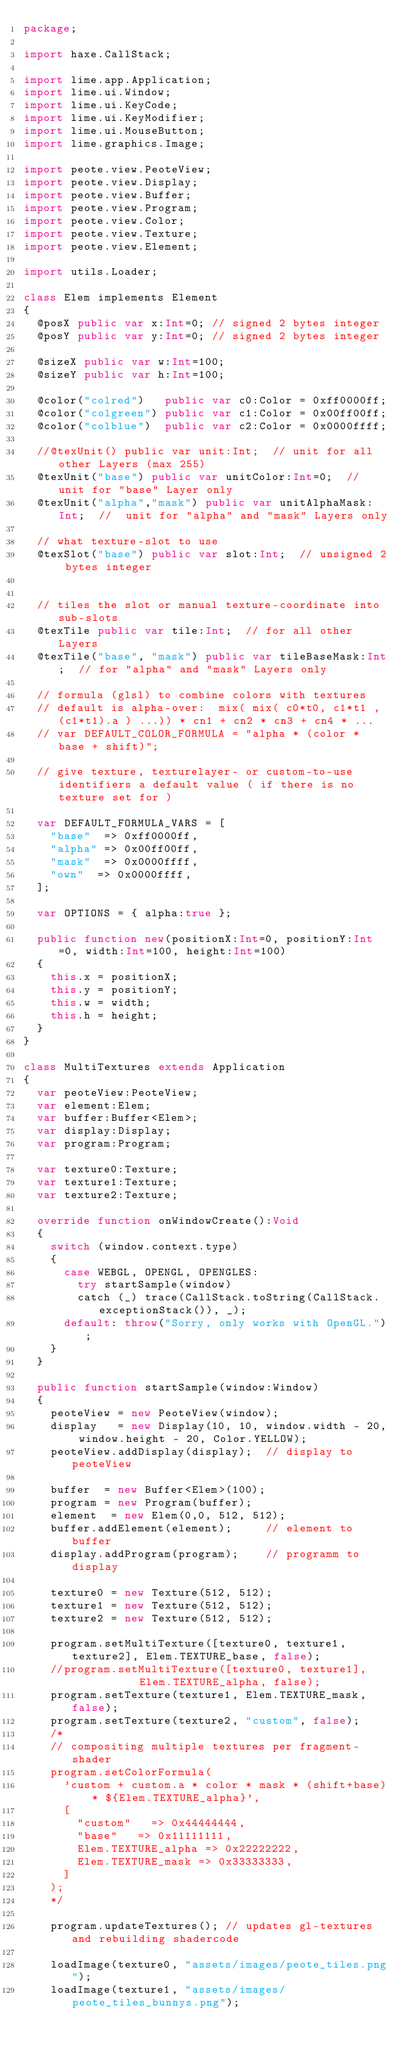<code> <loc_0><loc_0><loc_500><loc_500><_Haxe_>package;

import haxe.CallStack;

import lime.app.Application;
import lime.ui.Window;
import lime.ui.KeyCode;
import lime.ui.KeyModifier;
import lime.ui.MouseButton;
import lime.graphics.Image;

import peote.view.PeoteView;
import peote.view.Display;
import peote.view.Buffer;
import peote.view.Program;
import peote.view.Color;
import peote.view.Texture;
import peote.view.Element;

import utils.Loader;

class Elem implements Element
{
	@posX public var x:Int=0; // signed 2 bytes integer
	@posY public var y:Int=0; // signed 2 bytes integer
	
	@sizeX public var w:Int=100;
	@sizeY public var h:Int=100;
	
	@color("colred")   public var c0:Color = 0xff0000ff;
	@color("colgreen") public var c1:Color = 0x00ff00ff;
	@color("colblue")  public var c2:Color = 0x0000ffff;
		
	//@texUnit() public var unit:Int;  // unit for all other Layers (max 255)
	@texUnit("base") public var unitColor:Int=0;  //  unit for "base" Layer only
	@texUnit("alpha","mask") public var unitAlphaMask:Int;  //  unit for "alpha" and "mask" Layers only

	// what texture-slot to use
	@texSlot("base") public var slot:Int;  // unsigned 2 bytes integer


	// tiles the slot or manual texture-coordinate into sub-slots
	@texTile public var tile:Int;  // for all other Layers
	@texTile("base", "mask") public var tileBaseMask:Int;  // for "alpha" and "mask" Layers only

	// formula (glsl) to combine colors with textures
	// default is alpha-over:  mix( mix( c0*t0, c1*t1 , (c1*t1).a ) ...)) * cn1 + cn2 * cn3 + cn4 * ...
	// var DEFAULT_COLOR_FORMULA = "alpha * (color * base + shift)";

	// give texture, texturelayer- or custom-to-use identifiers a default value ( if there is no texture set for )
	
	var DEFAULT_FORMULA_VARS = [
		"base"  => 0xff0000ff,
		"alpha" => 0x00ff00ff,
		"mask"  => 0x0000ffff,
		"own"  => 0x0000ffff,
	];
	
	var OPTIONS = { alpha:true };
		
	public function new(positionX:Int=0, positionY:Int=0, width:Int=100, height:Int=100)
	{
		this.x = positionX;
		this.y = positionY;
		this.w = width;
		this.h = height;
	}
}

class MultiTextures extends Application
{
	var peoteView:PeoteView;
	var element:Elem;
	var buffer:Buffer<Elem>;
	var display:Display;
	var program:Program;
	
	var texture0:Texture;
	var texture1:Texture;
	var texture2:Texture;
	
	override function onWindowCreate():Void
	{
		switch (window.context.type)
		{
			case WEBGL, OPENGL, OPENGLES:
				try startSample(window)
				catch (_) trace(CallStack.toString(CallStack.exceptionStack()), _);
			default: throw("Sorry, only works with OpenGL.");
		}
	}

	public function startSample(window:Window)
	{
		peoteView = new PeoteView(window);
		display   = new Display(10, 10, window.width - 20, window.height - 20, Color.YELLOW);
		peoteView.addDisplay(display);  // display to peoteView
		
		buffer  = new Buffer<Elem>(100);
		program = new Program(buffer);
		element  = new Elem(0,0, 512, 512);
		buffer.addElement(element);     // element to buffer
		display.addProgram(program);    // programm to display
		
		texture0 = new Texture(512, 512);
		texture1 = new Texture(512, 512);
		texture2 = new Texture(512, 512);
		
		program.setMultiTexture([texture0, texture1, texture2], Elem.TEXTURE_base, false);
		//program.setMultiTexture([texture0, texture1],           Elem.TEXTURE_alpha, false);
		program.setTexture(texture1, Elem.TEXTURE_mask, false);
		program.setTexture(texture2, "custom", false);
		/*
		// compositing multiple textures per fragment-shader
		program.setColorFormula(
			'custom + custom.a * color * mask * (shift+base) * ${Elem.TEXTURE_alpha}',
			[
				"custom"   => 0x44444444,
				"base"   => 0x11111111,
				Elem.TEXTURE_alpha => 0x22222222,
				Elem.TEXTURE_mask => 0x33333333,
			]
		);
		*/
		
		program.updateTextures(); // updates gl-textures and rebuilding shadercode
				
		loadImage(texture0, "assets/images/peote_tiles.png");
		loadImage(texture1, "assets/images/peote_tiles_bunnys.png");</code> 